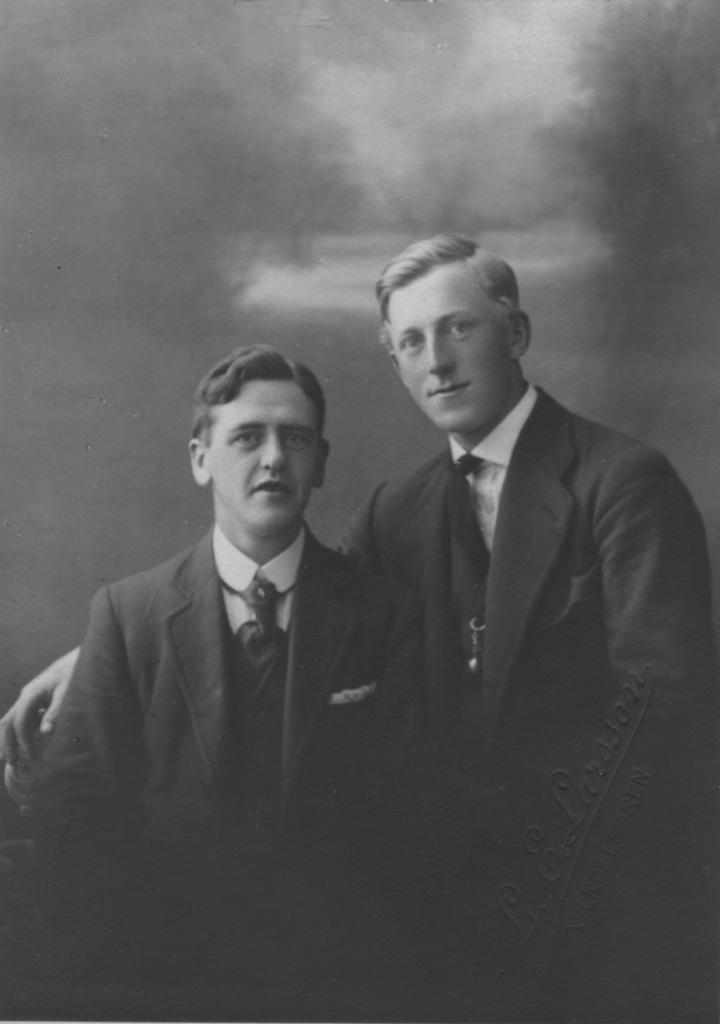What is the color scheme of the image? The image is black and white. How would you describe the background of the image? The background of the image is dark. Can you identify any people in the image? Yes, there are two men in the middle of the image. What type of beast can be seen in the image? There is no beast present in the image; it features two men in a black and white setting with a dark background. 